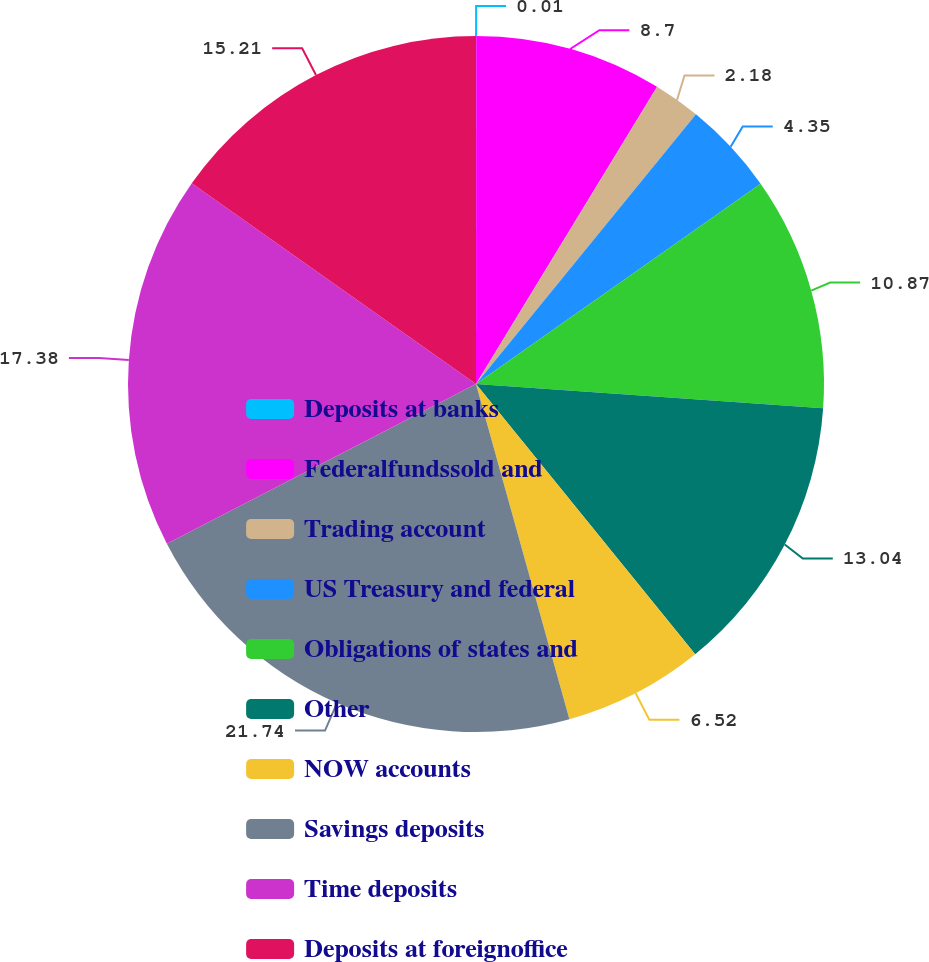<chart> <loc_0><loc_0><loc_500><loc_500><pie_chart><fcel>Deposits at banks<fcel>Federalfundssold and<fcel>Trading account<fcel>US Treasury and federal<fcel>Obligations of states and<fcel>Other<fcel>NOW accounts<fcel>Savings deposits<fcel>Time deposits<fcel>Deposits at foreignoffice<nl><fcel>0.01%<fcel>8.7%<fcel>2.18%<fcel>4.35%<fcel>10.87%<fcel>13.04%<fcel>6.52%<fcel>21.73%<fcel>17.38%<fcel>15.21%<nl></chart> 